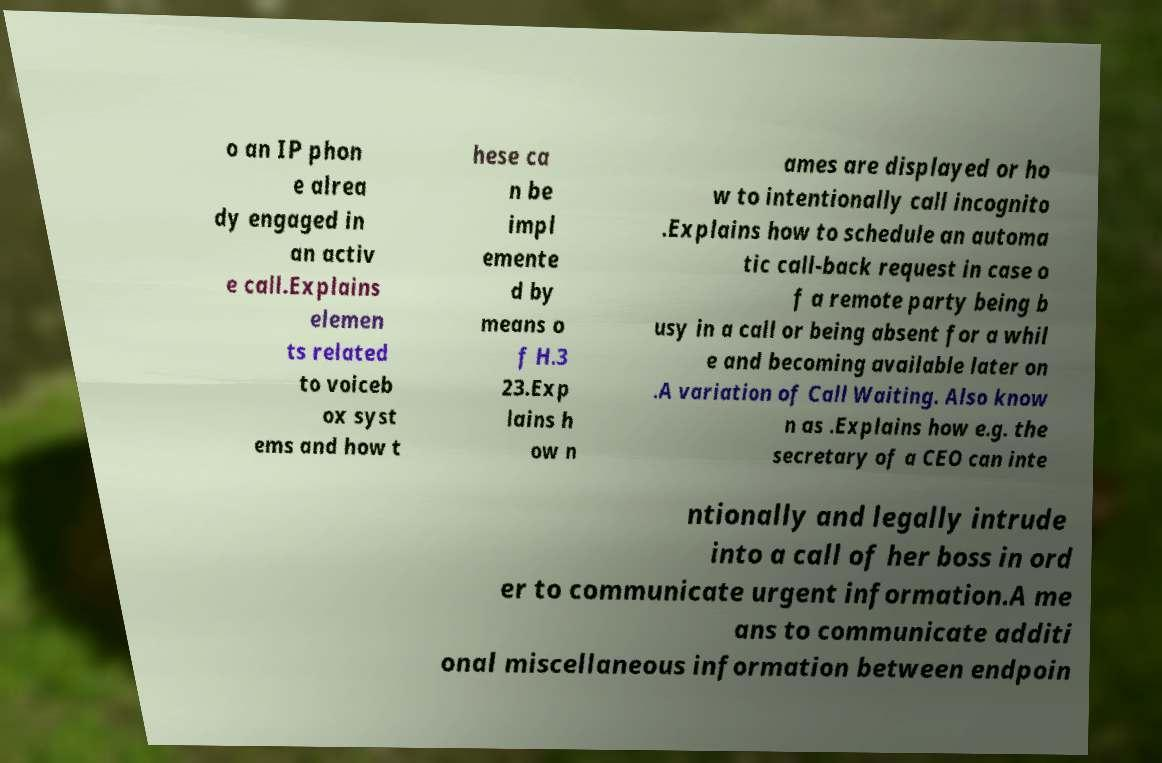Can you accurately transcribe the text from the provided image for me? o an IP phon e alrea dy engaged in an activ e call.Explains elemen ts related to voiceb ox syst ems and how t hese ca n be impl emente d by means o f H.3 23.Exp lains h ow n ames are displayed or ho w to intentionally call incognito .Explains how to schedule an automa tic call-back request in case o f a remote party being b usy in a call or being absent for a whil e and becoming available later on .A variation of Call Waiting. Also know n as .Explains how e.g. the secretary of a CEO can inte ntionally and legally intrude into a call of her boss in ord er to communicate urgent information.A me ans to communicate additi onal miscellaneous information between endpoin 